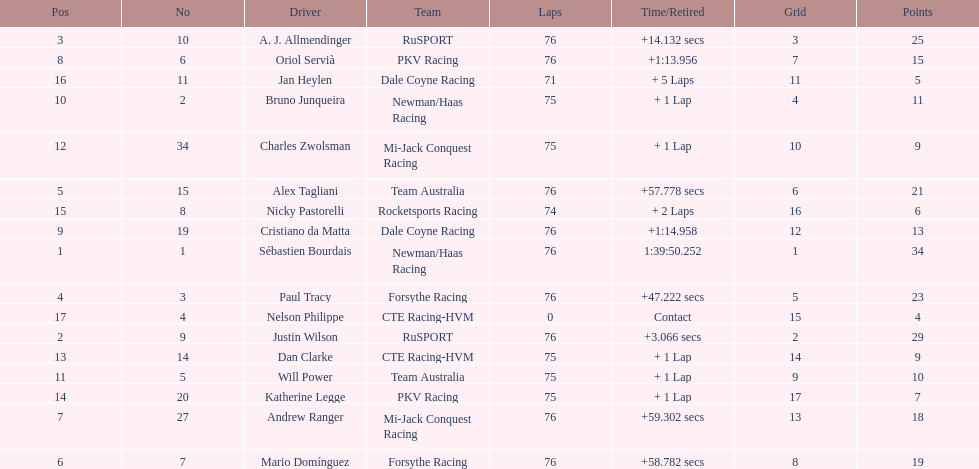Which driver earned the least amount of points. Nelson Philippe. 